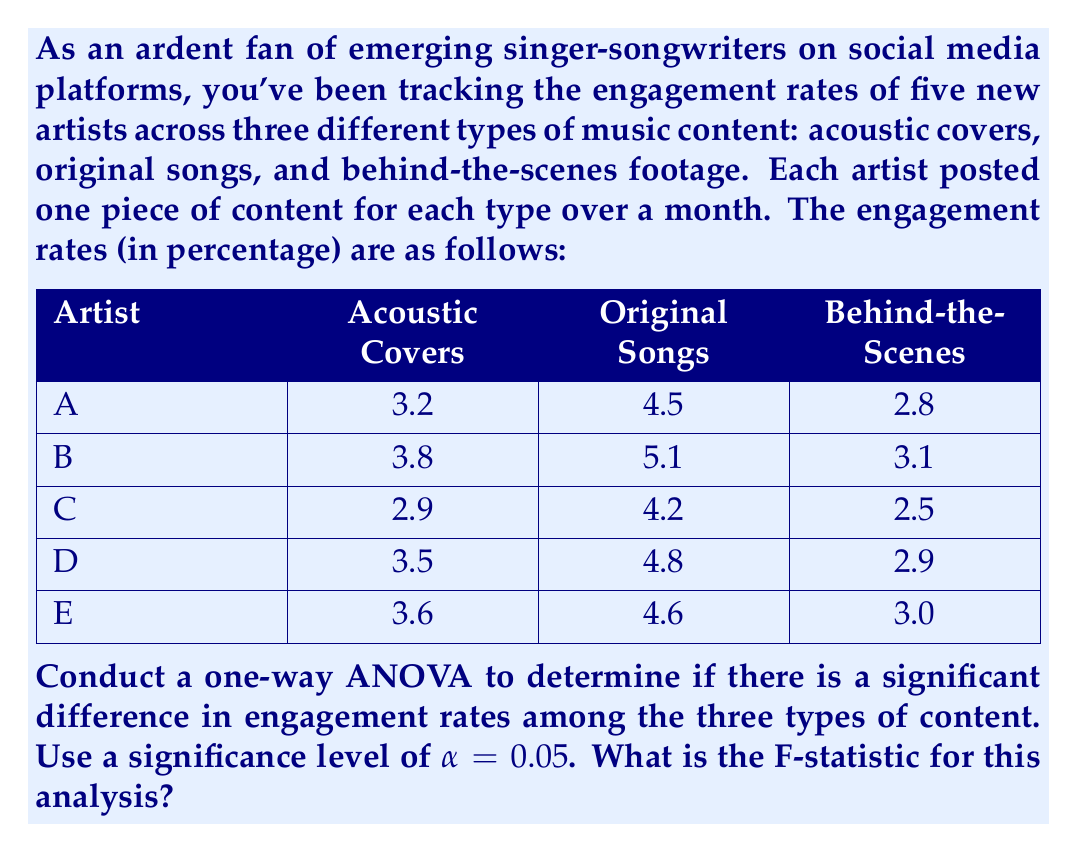Can you solve this math problem? To conduct a one-way ANOVA, we need to follow these steps:

1. Calculate the mean for each group (content type) and the overall mean.
2. Calculate the sum of squares between groups (SSB) and within groups (SSW).
3. Calculate the degrees of freedom for between groups (dfB) and within groups (dfW).
4. Calculate the mean square between groups (MSB) and within groups (MSW).
5. Calculate the F-statistic.

Step 1: Calculate means
Acoustic Covers mean: $\bar{X}_A = \frac{3.2 + 3.8 + 2.9 + 3.5 + 3.6}{5} = 3.4$
Original Songs mean: $\bar{X}_O = \frac{4.5 + 5.1 + 4.2 + 4.8 + 4.6}{5} = 4.64$
Behind-the-Scenes mean: $\bar{X}_B = \frac{2.8 + 3.1 + 2.5 + 2.9 + 3.0}{5} = 2.86$
Overall mean: $\bar{X} = \frac{3.4 + 4.64 + 2.86}{3} = 3.63$

Step 2: Calculate SSB and SSW
SSB = $n\sum_{i=1}^k (\bar{X}_i - \bar{X})^2$
    = $5[(3.4 - 3.63)^2 + (4.64 - 3.63)^2 + (2.86 - 3.63)^2]$
    = $5(0.0529 + 1.0201 + 0.5929)$
    = $8.3295$

SSW = $\sum_{i=1}^k \sum_{j=1}^n (X_{ij} - \bar{X}_i)^2$
    = $[(3.2 - 3.4)^2 + (3.8 - 3.4)^2 + (2.9 - 3.4)^2 + (3.5 - 3.4)^2 + (3.6 - 3.4)^2]$
    + $[(4.5 - 4.64)^2 + (5.1 - 4.64)^2 + (4.2 - 4.64)^2 + (4.8 - 4.64)^2 + (4.6 - 4.64)^2]$
    + $[(2.8 - 2.86)^2 + (3.1 - 2.86)^2 + (2.5 - 2.86)^2 + (2.9 - 2.86)^2 + (3.0 - 2.86)^2]$
    = $0.69 + 0.468 + 0.228$
    = $1.386$

Step 3: Calculate degrees of freedom
dfB = k - 1 = 3 - 1 = 2
dfW = N - k = 15 - 3 = 12

Step 4: Calculate MSB and MSW
MSB = $\frac{SSB}{dfB} = \frac{8.3295}{2} = 4.16475$
MSW = $\frac{SSW}{dfW} = \frac{1.386}{12} = 0.1155$

Step 5: Calculate F-statistic
F = $\frac{MSB}{MSW} = \frac{4.16475}{0.1155} = 36.0584$
Answer: The F-statistic for this one-way ANOVA is approximately 36.0584. 